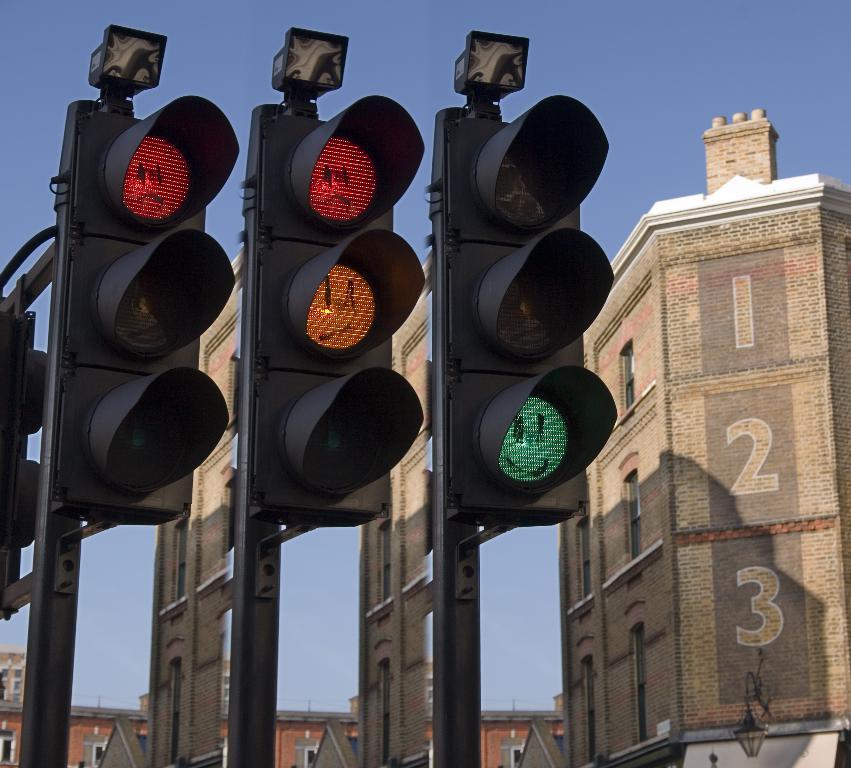What is the smallest number written on the building?
Your answer should be compact. 1. What is the number written on the middle floor?
Your response must be concise. 2. 